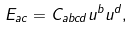<formula> <loc_0><loc_0><loc_500><loc_500>E _ { a c } = C _ { a b c d } u ^ { b } u ^ { d } ,</formula> 